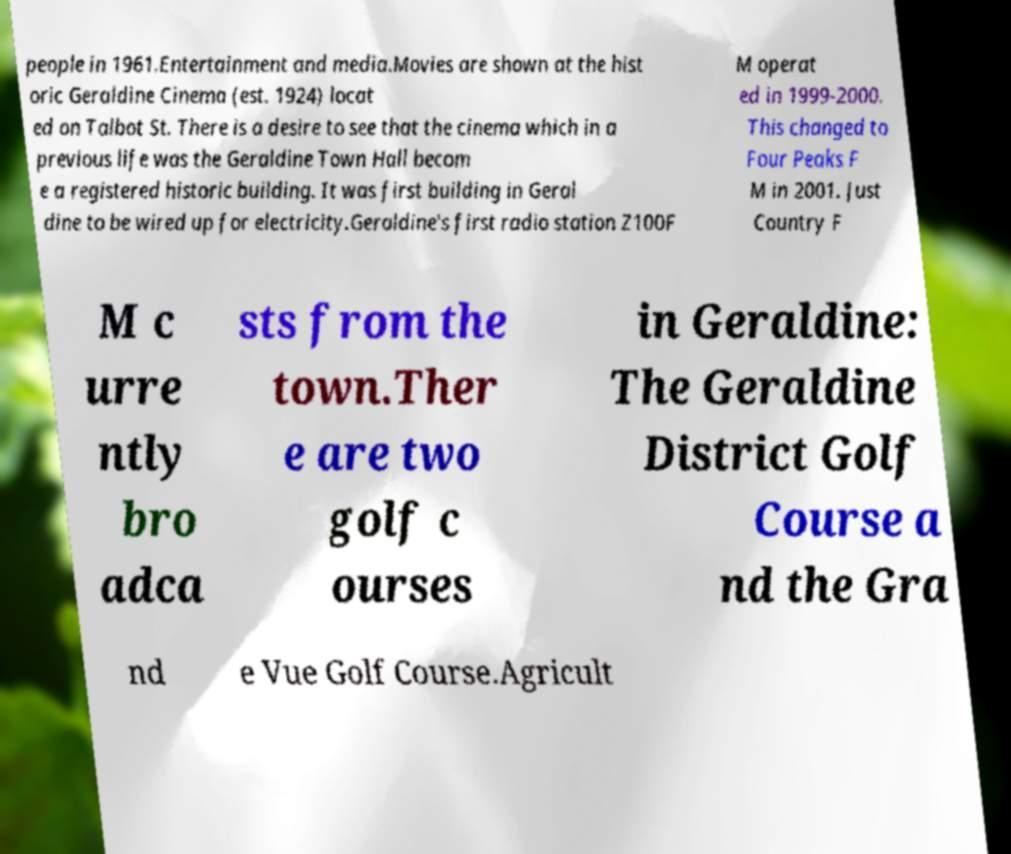I need the written content from this picture converted into text. Can you do that? people in 1961.Entertainment and media.Movies are shown at the hist oric Geraldine Cinema (est. 1924) locat ed on Talbot St. There is a desire to see that the cinema which in a previous life was the Geraldine Town Hall becom e a registered historic building. It was first building in Geral dine to be wired up for electricity.Geraldine's first radio station Z100F M operat ed in 1999-2000. This changed to Four Peaks F M in 2001. Just Country F M c urre ntly bro adca sts from the town.Ther e are two golf c ourses in Geraldine: The Geraldine District Golf Course a nd the Gra nd e Vue Golf Course.Agricult 